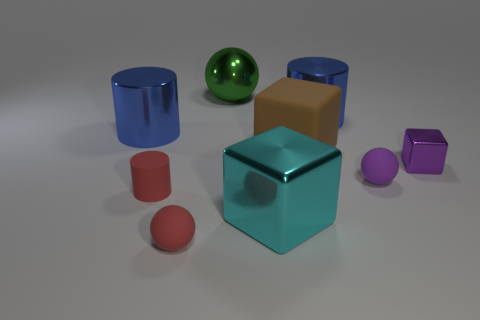How many small objects are the same color as the small metallic block?
Make the answer very short. 1. There is a matte object that is on the right side of the big green ball and in front of the big matte block; how big is it?
Make the answer very short. Small. There is a tiny sphere that is the same color as the tiny metal object; what material is it?
Your answer should be very brief. Rubber. What number of big green objects are there?
Offer a very short reply. 1. Are there fewer large blue rubber cylinders than blue objects?
Make the answer very short. Yes. What is the material of the green ball that is the same size as the brown matte cube?
Offer a very short reply. Metal. How many objects are either small purple matte spheres or big green blocks?
Make the answer very short. 1. How many large things are both behind the tiny purple ball and in front of the large brown object?
Provide a short and direct response. 0. Are there fewer big brown rubber blocks left of the brown rubber thing than large metal objects?
Your answer should be very brief. Yes. The green shiny thing that is the same size as the matte block is what shape?
Provide a short and direct response. Sphere. 